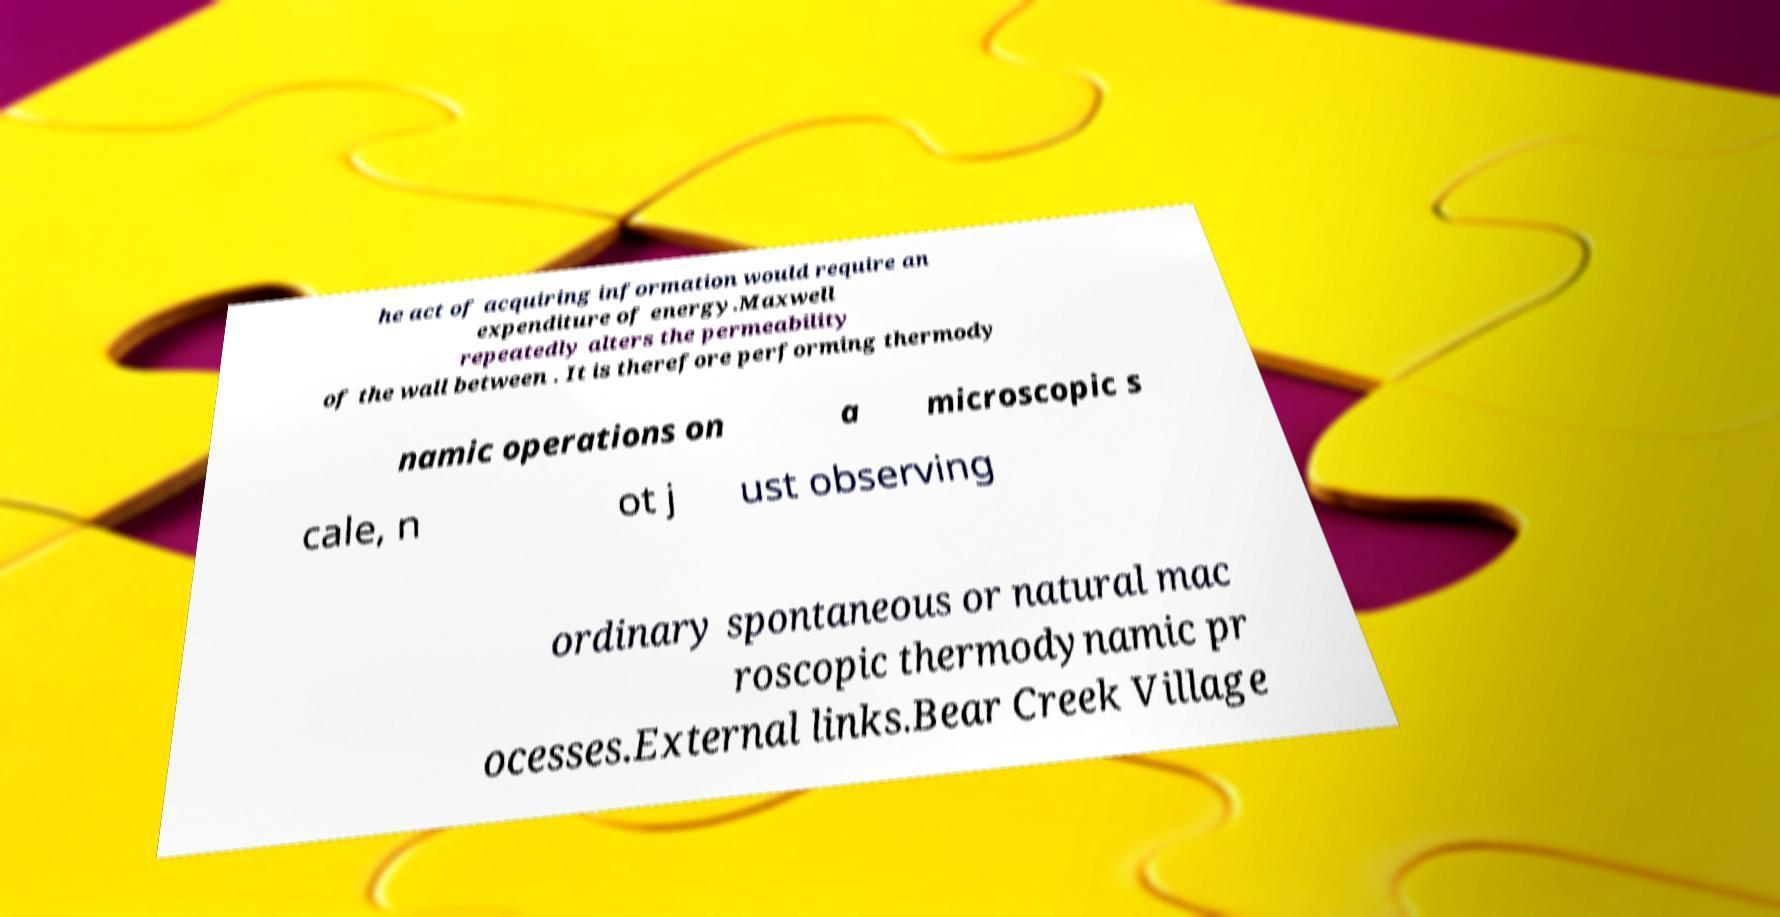Please read and relay the text visible in this image. What does it say? he act of acquiring information would require an expenditure of energy.Maxwell repeatedly alters the permeability of the wall between . It is therefore performing thermody namic operations on a microscopic s cale, n ot j ust observing ordinary spontaneous or natural mac roscopic thermodynamic pr ocesses.External links.Bear Creek Village 